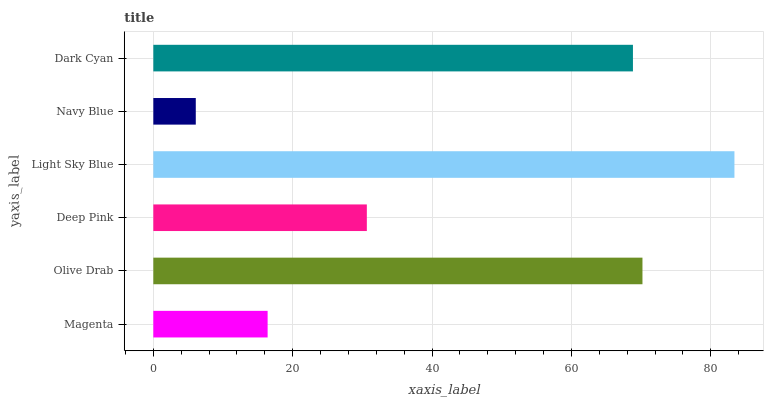Is Navy Blue the minimum?
Answer yes or no. Yes. Is Light Sky Blue the maximum?
Answer yes or no. Yes. Is Olive Drab the minimum?
Answer yes or no. No. Is Olive Drab the maximum?
Answer yes or no. No. Is Olive Drab greater than Magenta?
Answer yes or no. Yes. Is Magenta less than Olive Drab?
Answer yes or no. Yes. Is Magenta greater than Olive Drab?
Answer yes or no. No. Is Olive Drab less than Magenta?
Answer yes or no. No. Is Dark Cyan the high median?
Answer yes or no. Yes. Is Deep Pink the low median?
Answer yes or no. Yes. Is Light Sky Blue the high median?
Answer yes or no. No. Is Dark Cyan the low median?
Answer yes or no. No. 